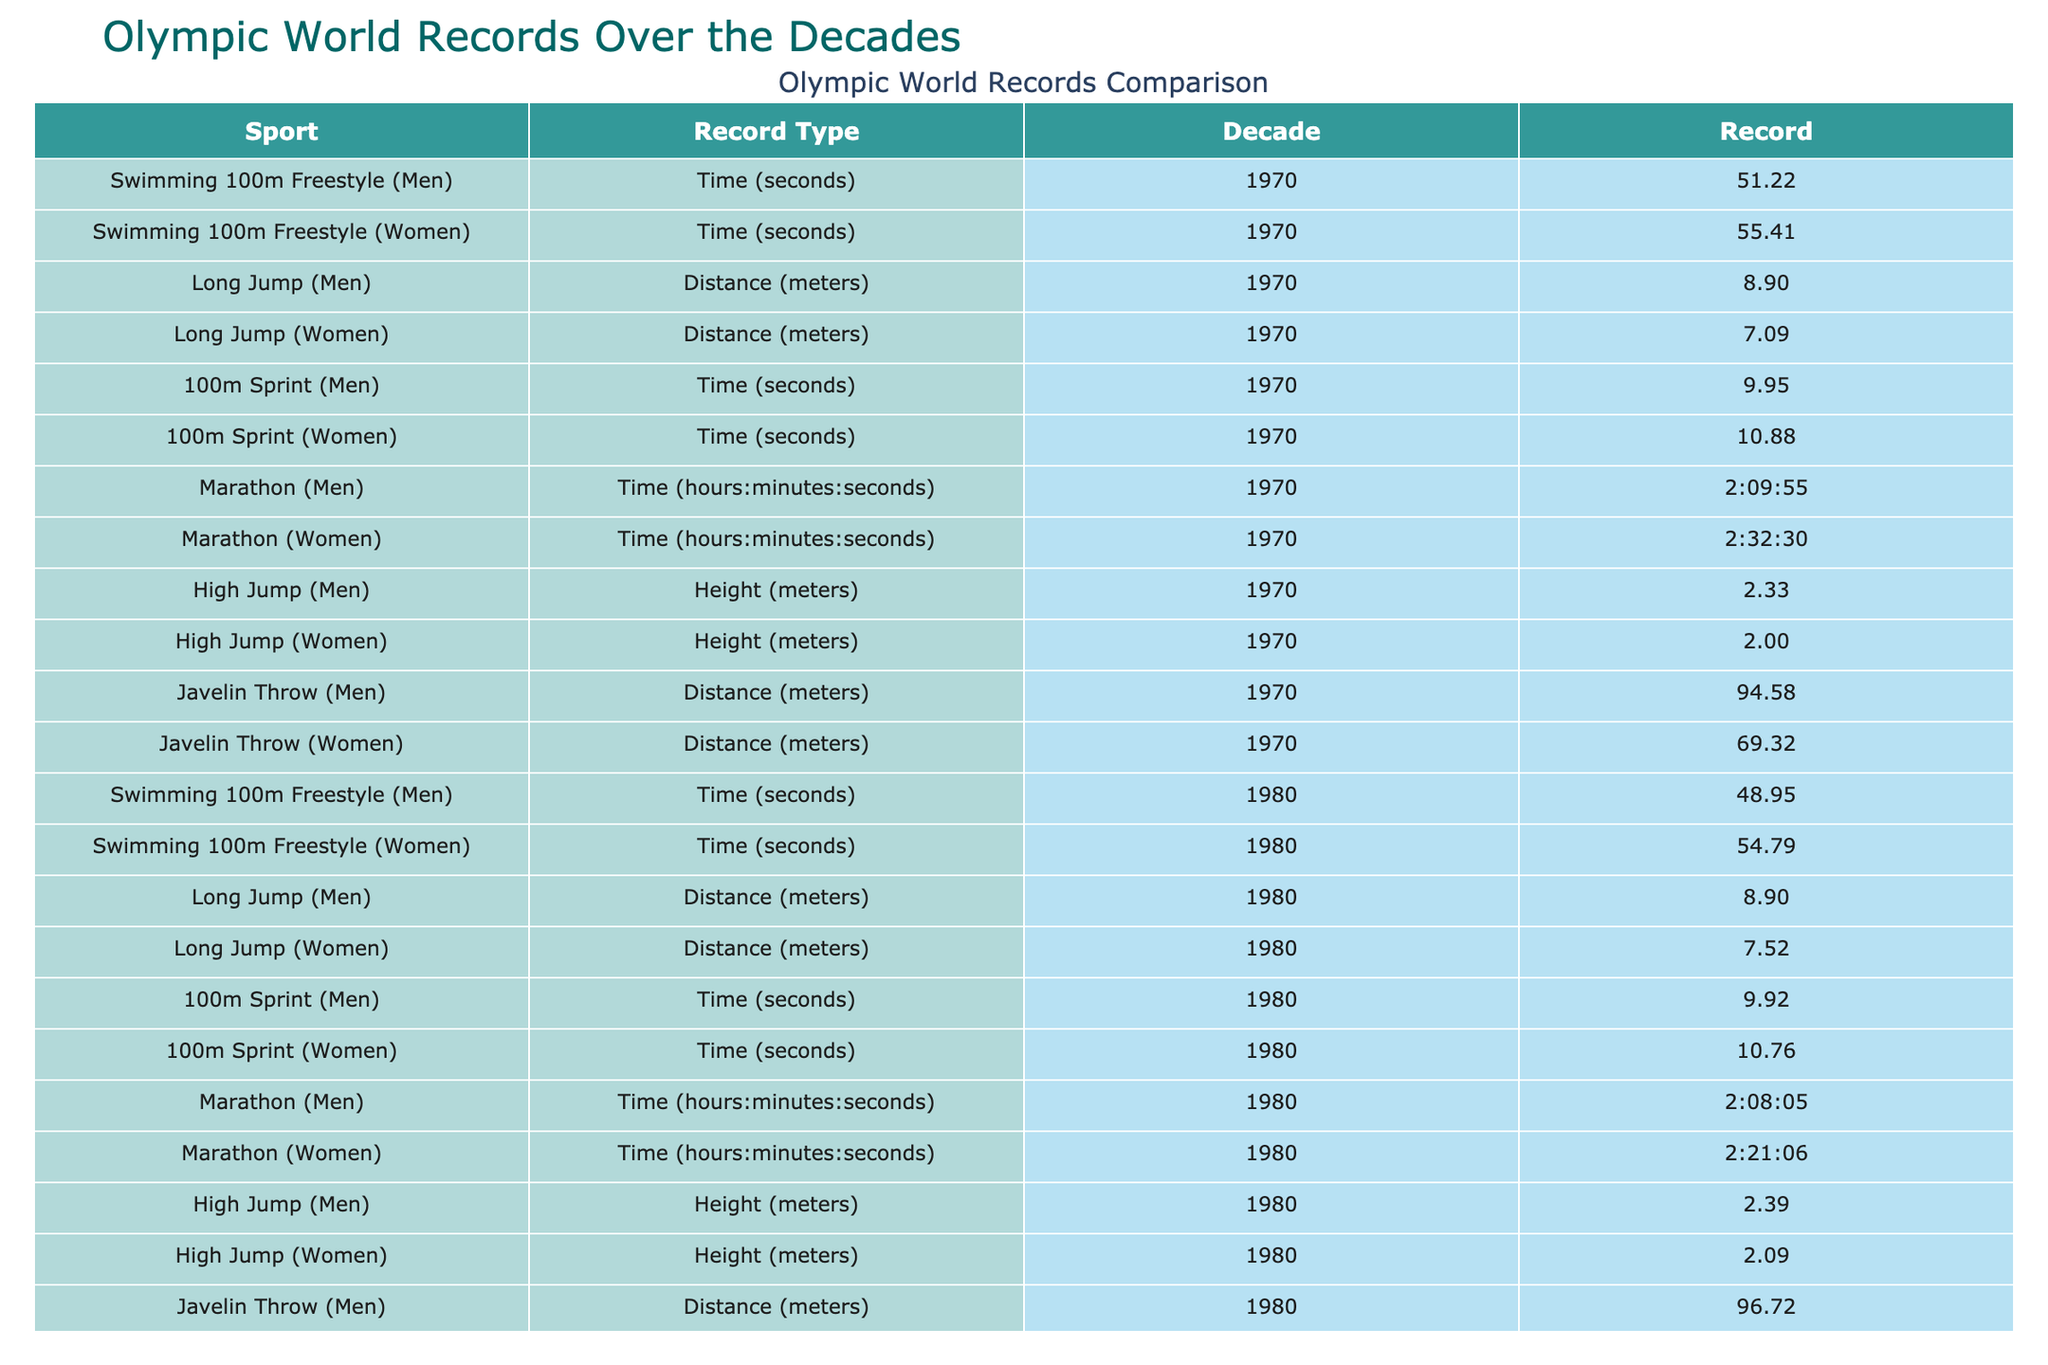What was the world record time for men's 100m freestyle swimming in the 2000s? The table shows that the world record time for men's 100m freestyle swimming in the 2000s was 47.05 seconds.
Answer: 47.05 seconds What distance did the women's long jump reach in the 1980s? According to the table, the women's long jump distance in the 1980s was 7.52 meters.
Answer: 7.52 meters Is it true that the men's marathon record improved in each decade listed? By analyzing the marathon record times in each decade, we can see that it improved from 2:09:55 in the 1970s to 2:01:39 in the 2020s, confirming an improvement in each decade.
Answer: Yes What was the difference in the world record heights for men's high jump between the 1970s and the 2020s? The record for men's high jump was 2.33 meters in the 1970s and 2.45 meters in the 2020s, resulting in a difference of 0.12 meters.
Answer: 0.12 meters Which sport has seen no increase in records from the 1970s to the 2020s for men's long jump? The men's long jump record has consistently remained at 8.95 meters from the 1990s through to the 2020s, indicating no increase since then.
Answer: Men's long jump What was the average record time for the women's 100m sprint over the decades listed? To find the average time: (10.88 + 10.76 + 10.49 + 10.49 + 10.49 + 10.61) / 6 = 10.594 seconds.
Answer: 10.594 seconds Which Olympic sport had the highest distance record for men in the 1990s? The table indicates that the javelin throw had the highest distance record of 98.48 meters for men in the 1990s, compared to other sports.
Answer: Javelin throw Did the women's marathon record improve between the 2010s and 2020s? The marathon record for women was 2:14:04 in both the 2010s and the 2020s, indicating no improvement during that period.
Answer: No What is the highest women's long jump recorded across all decades listed? By examining the distances, the highest women's long jump recorded is 7.52 meters, which occurred during the 1980s, 1990s, 2000s, and 2010s.
Answer: 7.52 meters 